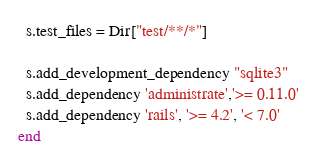<code> <loc_0><loc_0><loc_500><loc_500><_Ruby_>  s.test_files = Dir["test/**/*"]

  s.add_development_dependency "sqlite3"
  s.add_dependency 'administrate','>= 0.11.0'
  s.add_dependency 'rails', '>= 4.2', '< 7.0'
end
</code> 